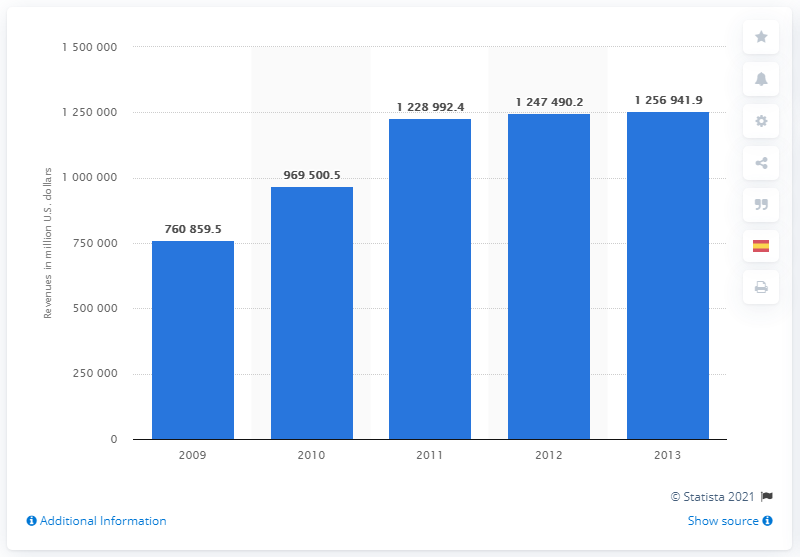Outline some significant characteristics in this image. In 2013, the global total revenue of the oil and gas industry was 125,694,199.9. In 2009, the global oil and gas industry generated a total revenue of 760,859.5. In 2011, the total revenue of the oil and gas industry was 122,899,249 dollars. 